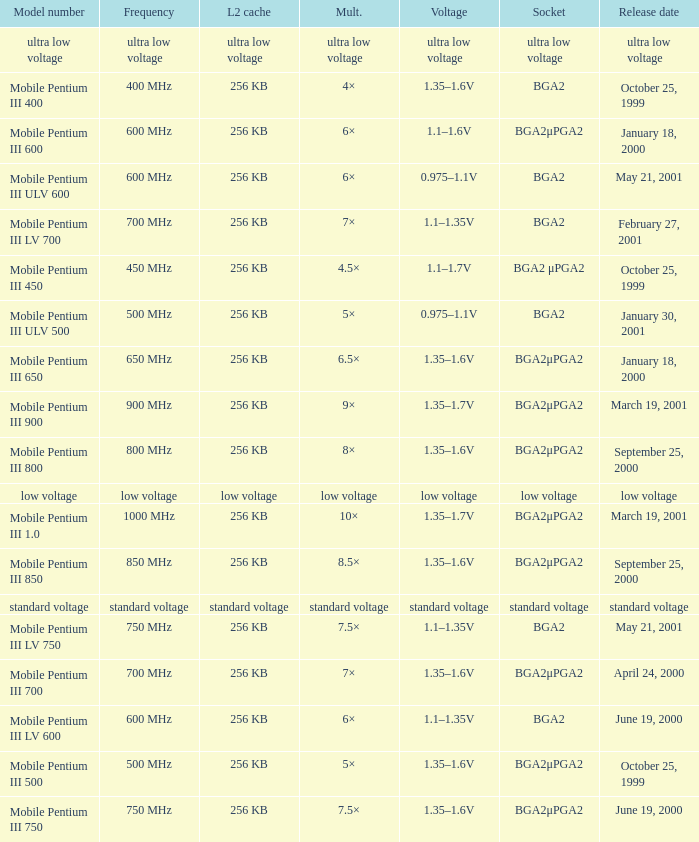What model number uses standard voltage socket? Standard voltage. 